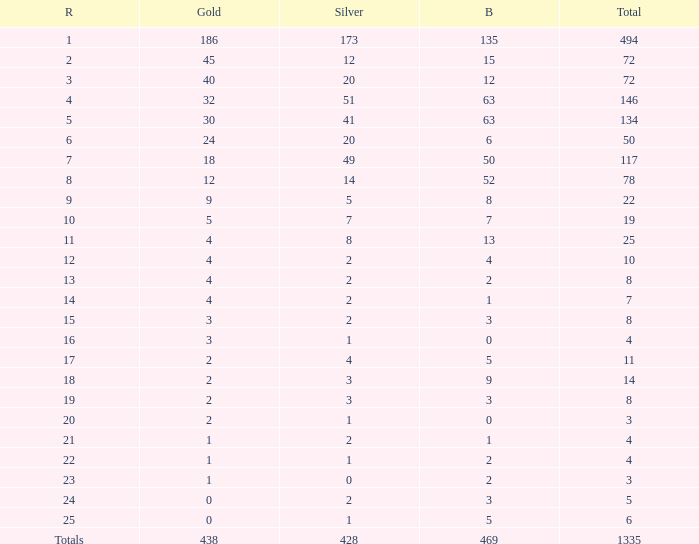What is the total amount of gold medals when there were more than 20 silvers and there were 135 bronze medals? 1.0. 